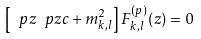Convert formula to latex. <formula><loc_0><loc_0><loc_500><loc_500>\left [ \ p z \ p z c + m _ { k , l } ^ { 2 } \right ] F ^ { ( p ) } _ { k , l } ( z ) = 0</formula> 